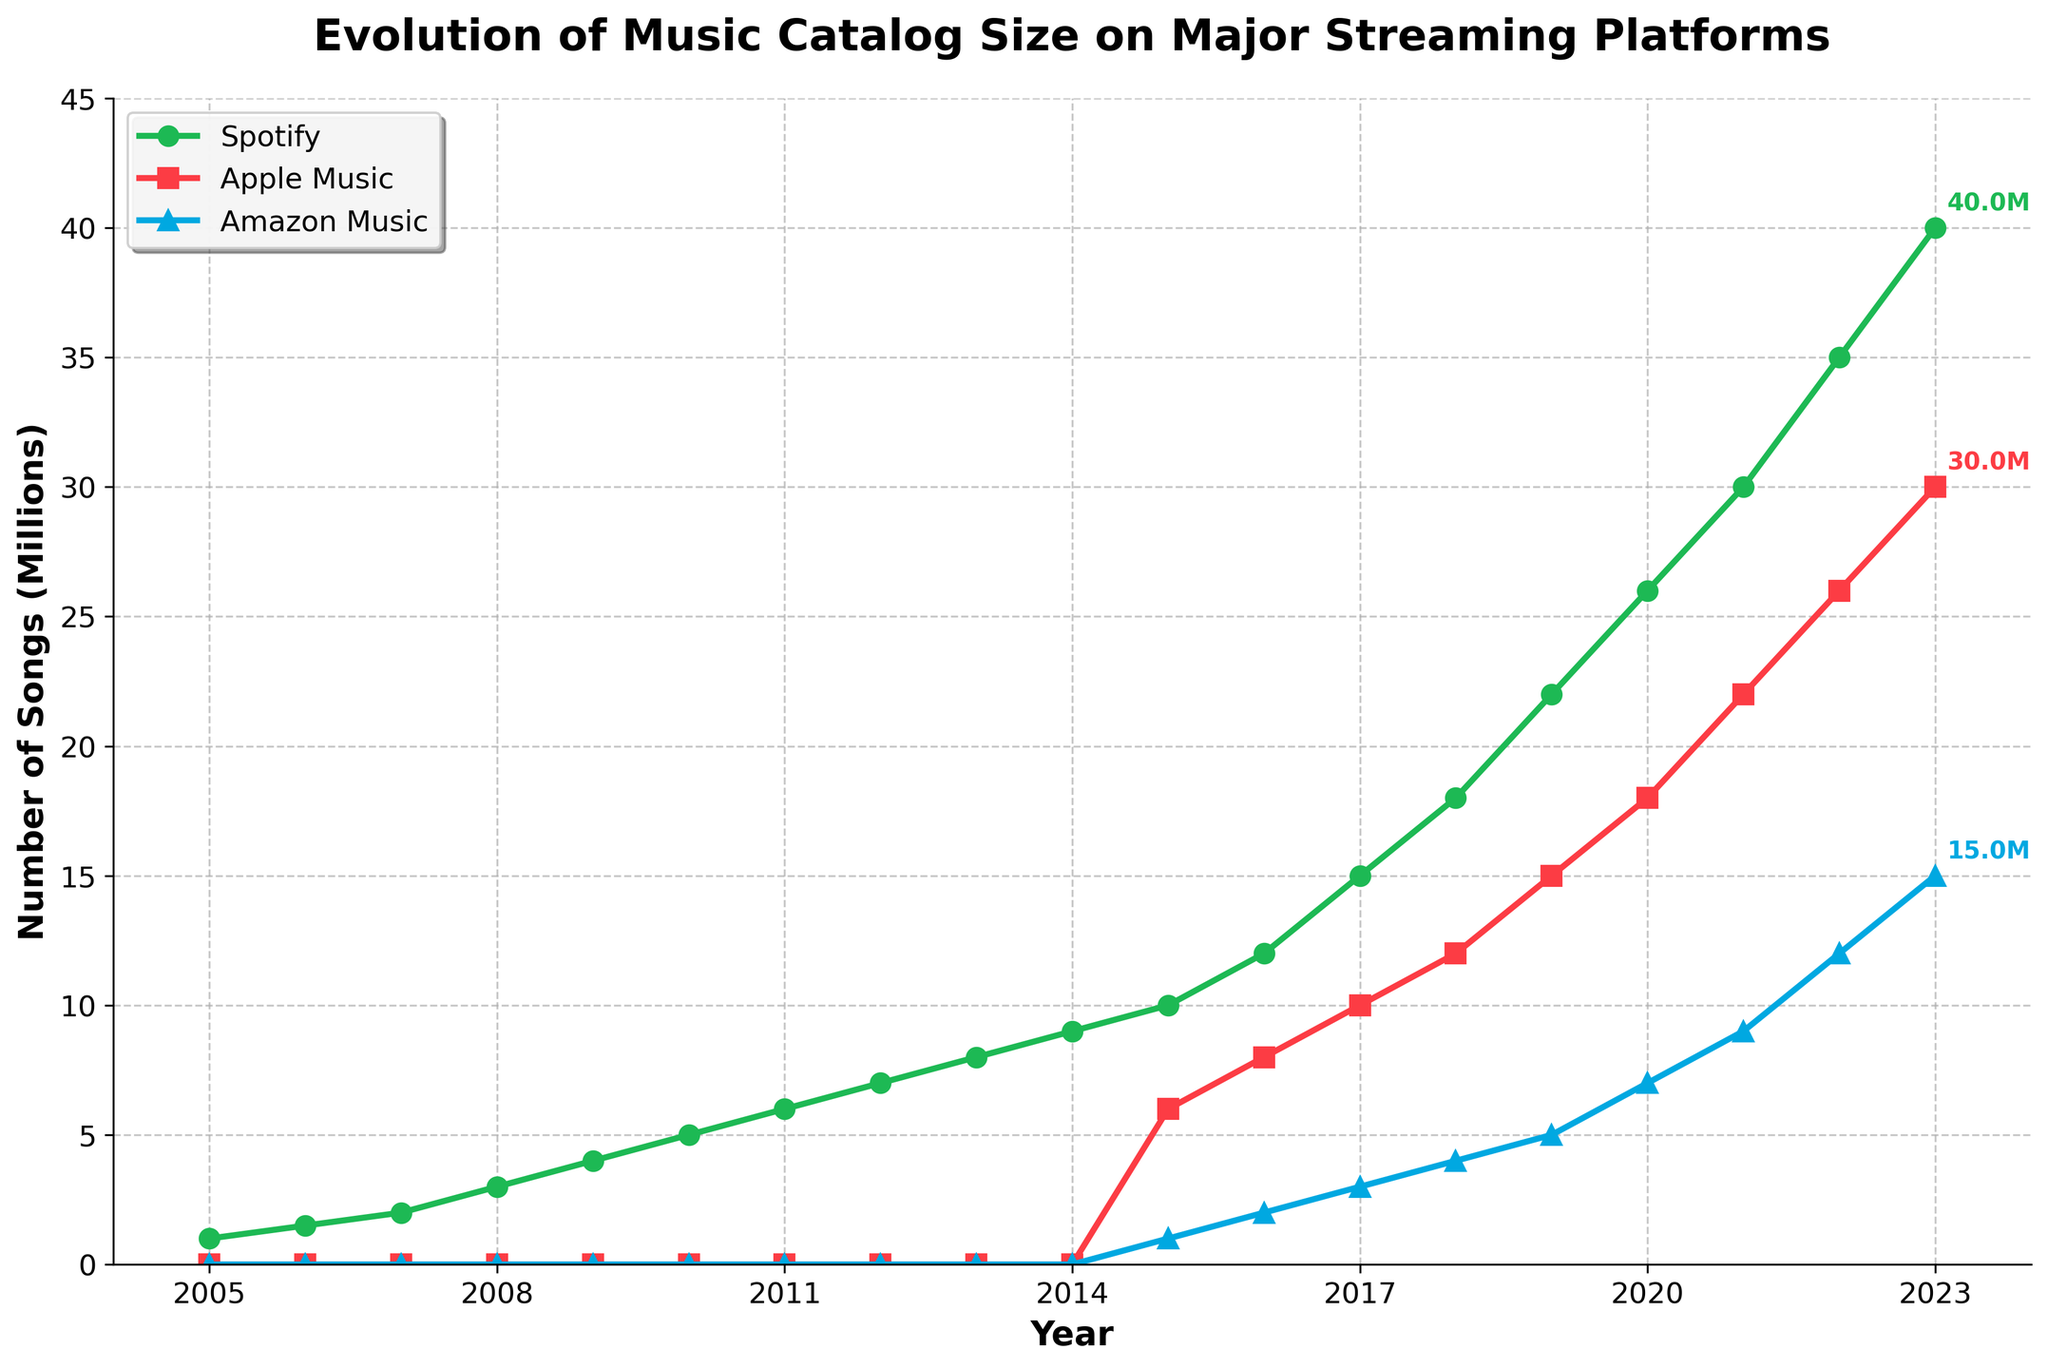Which platform had the highest number of songs released in 2023? From the figure, look for the highest line among the platforms in 2023. The green line, representing Spotify, is at the top in 2023, indicating it has the highest number of songs released.
Answer: Spotify When did Apple Music first appear in the data? Find the first year where the red line (Apple Music) is shown in the chart. It starts in 2015.
Answer: 2015 How many songs were released on Spotify in 2008 compared to Amazon Music in 2023? Check the values on the Y-axis for Spotify in 2008 and Amazon Music in 2023. Spotify in 2008 shows 3 million, and Amazon Music in 2023 has 15 million. Compare the two values.
Answer: 3 million (Spotify 2008) vs. 15 million (Amazon Music 2023) Which year saw the largest increase in the number of songs released on Apple Music? Look at the red line representing Apple Music and find the year with the steepest upward slope. The steepest increase occurs between 2019 and 2020.
Answer: 2019 to 2020 How many more songs were released on Spotify in 2020 compared to Apple Music in 2020? In 2020, Spotify released 26 million songs and Apple Music released 18 million songs. The difference is 26 - 18 = 8 million.
Answer: 8 million What is the color of the line representing Amazon Music? Refer to the visual attribute of the line representing Amazon Music. It is colored blue.
Answer: Blue What trend is observed in the number of songs released on all three platforms over the years? Observe the general direction of the lines for Spotify, Apple Music, and Amazon Music. All lines show an upward trend, indicating increasing numbers of songs released over time.
Answer: Upward trend Which platform experienced the most steady growth throughout the period? Examine the smoothness of the lines representing each platform. Spotify's green line shows steady growth without sharp peaks or valleys.
Answer: Spotify What is the approximate difference in the number of songs released on Spotify between 2015 and 2023? Spotify had 10 million songs in 2015 and 40 million songs in 2023. The approximate difference is 40 - 10 = 30 million.
Answer: 30 million In which year did Amazon Music release 4 million songs? Look at the point where the blue line (Amazon Music) hits the 4 million mark on the Y-axis. This occurs in 2018.
Answer: 2018 